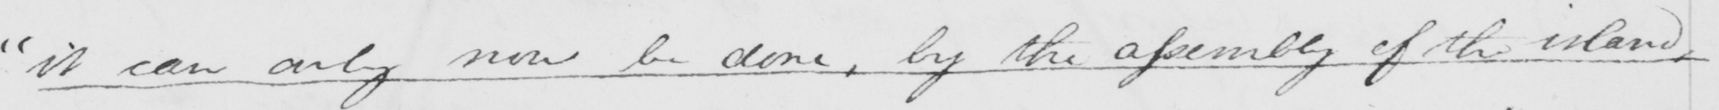Please provide the text content of this handwritten line. " it can only now be done , by the assembly of the island , 